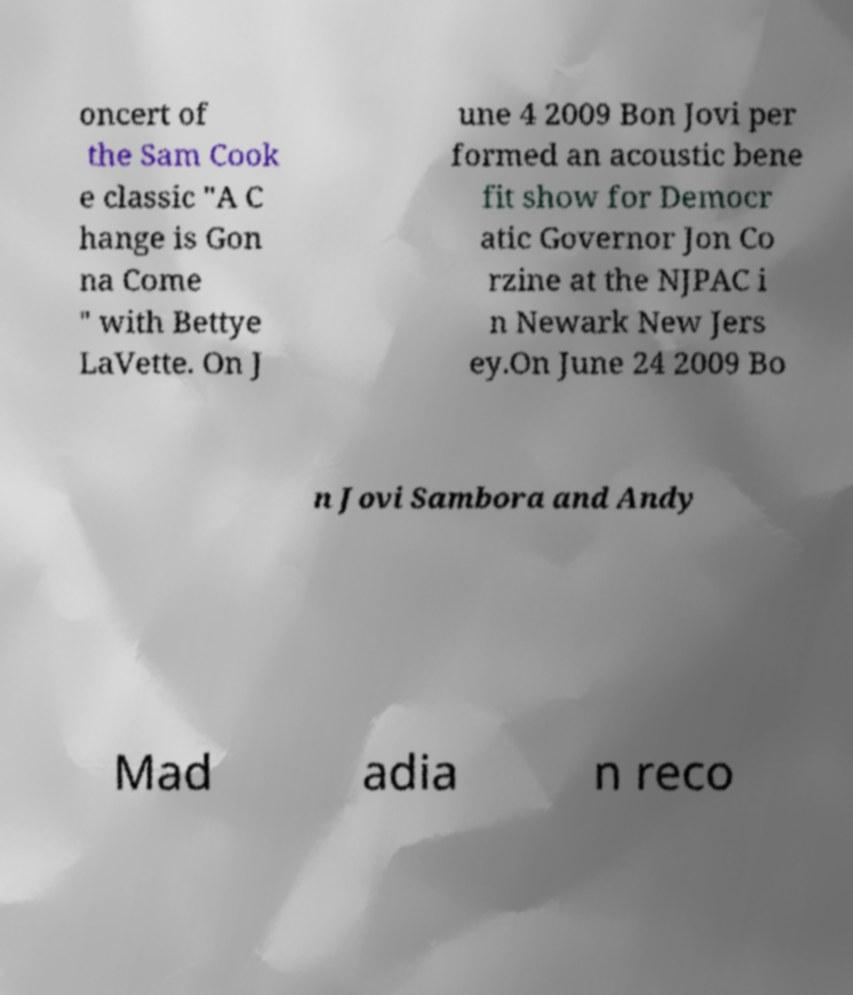What messages or text are displayed in this image? I need them in a readable, typed format. oncert of the Sam Cook e classic "A C hange is Gon na Come " with Bettye LaVette. On J une 4 2009 Bon Jovi per formed an acoustic bene fit show for Democr atic Governor Jon Co rzine at the NJPAC i n Newark New Jers ey.On June 24 2009 Bo n Jovi Sambora and Andy Mad adia n reco 